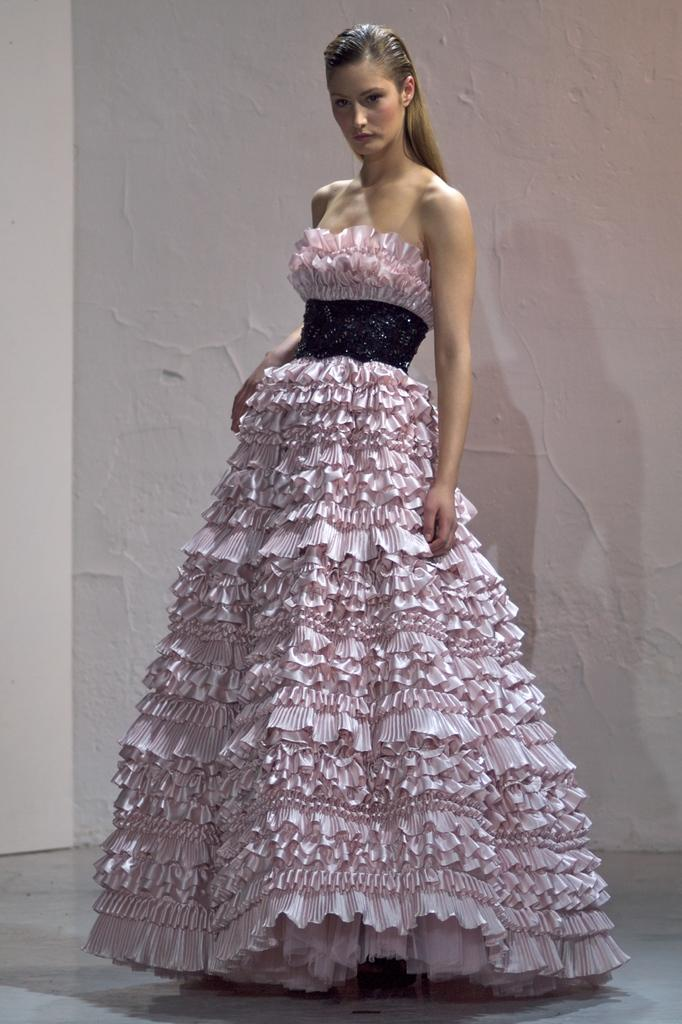What is the main subject of the image? There is a person standing in the image. What is the person wearing? The person is wearing a pink and black color dress. What can be seen in the background of the image? The background of the image includes a wall in cream color. How many pencils can be seen on the person's head in the image? There are no pencils visible on the person's head in the image. What type of bird is perched on the person's shoulder in the image? There is no bird present on the person's shoulder in the image. 